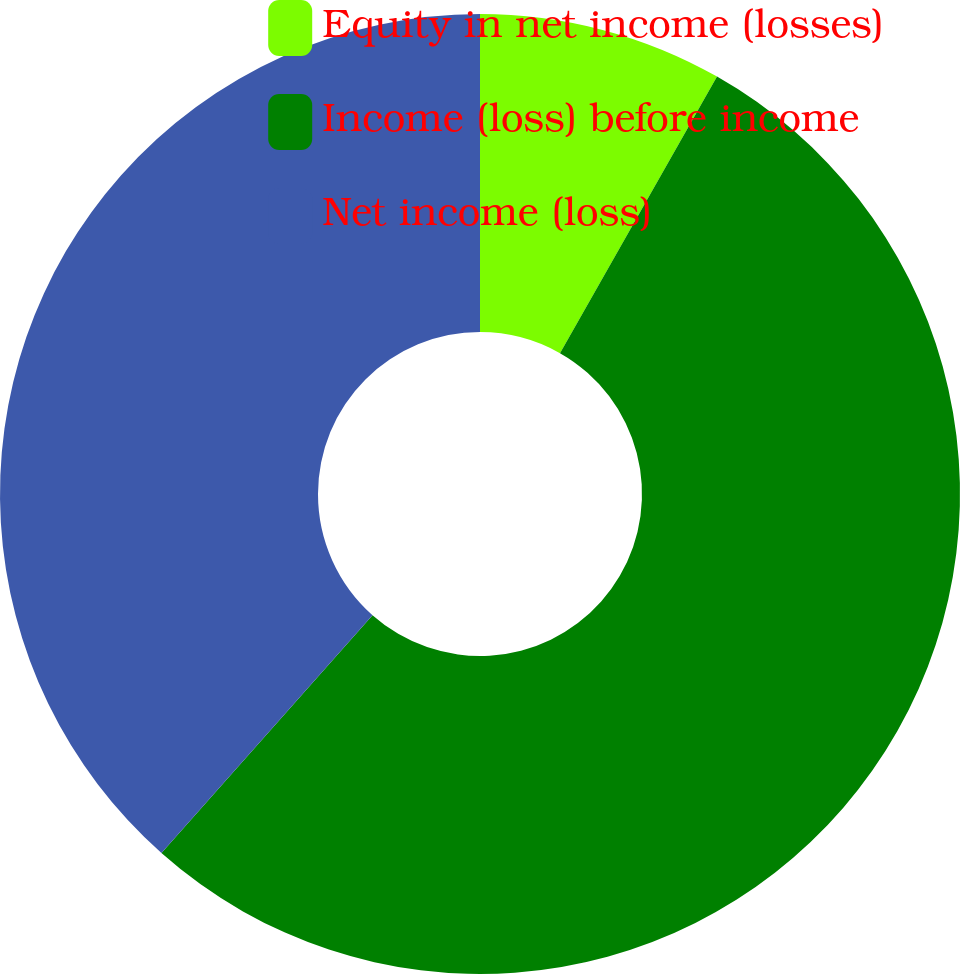<chart> <loc_0><loc_0><loc_500><loc_500><pie_chart><fcel>Equity in net income (losses)<fcel>Income (loss) before income<fcel>Net income (loss)<nl><fcel>8.22%<fcel>53.33%<fcel>38.45%<nl></chart> 